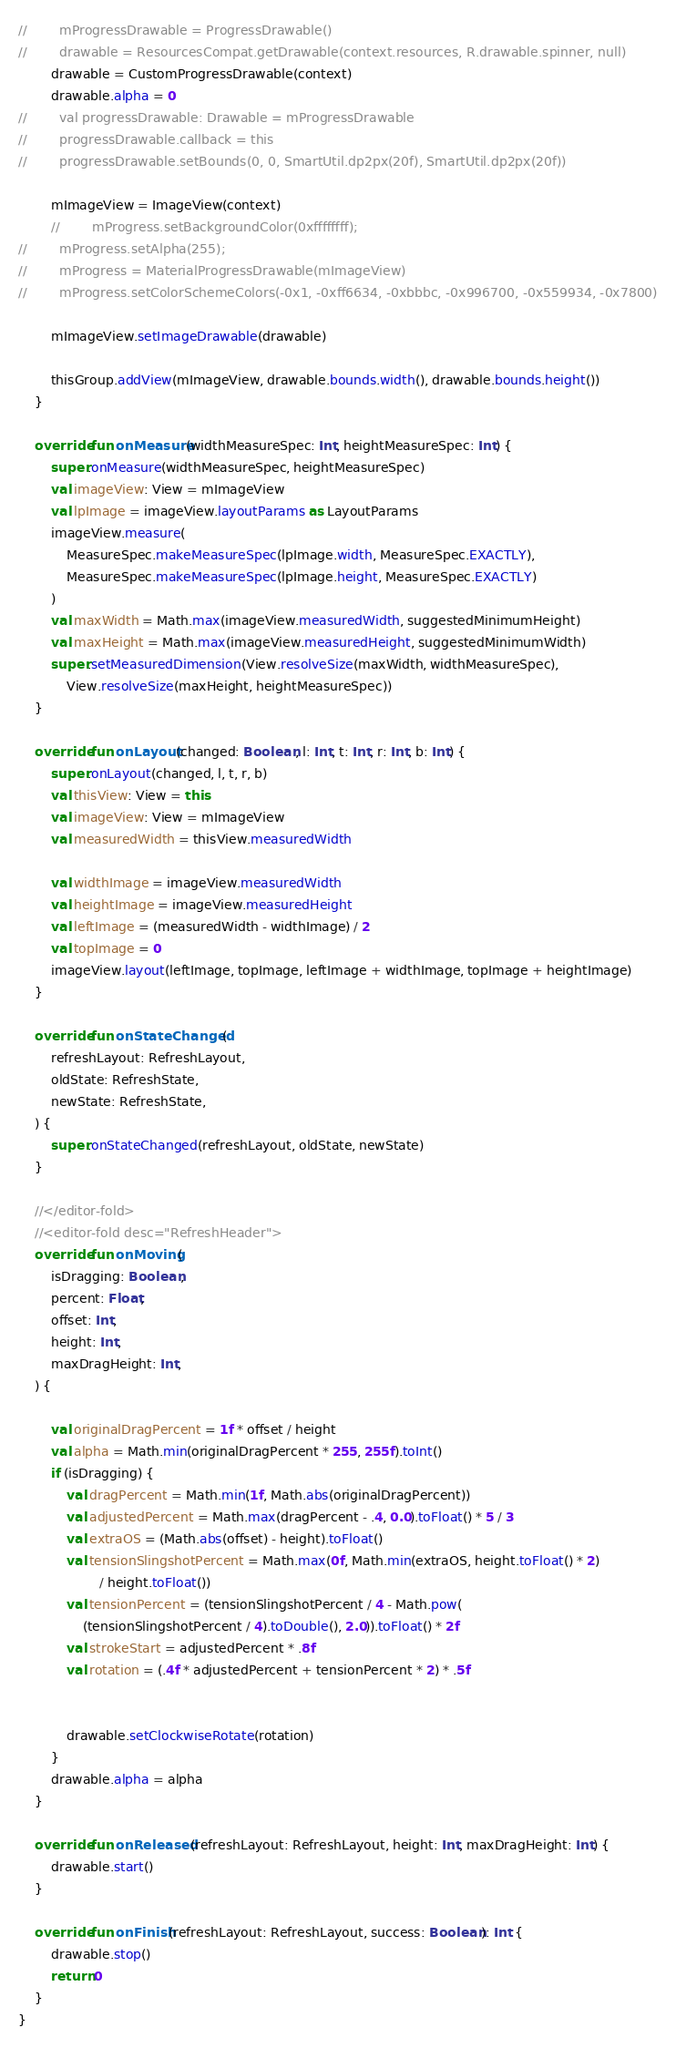Convert code to text. <code><loc_0><loc_0><loc_500><loc_500><_Kotlin_>
//        mProgressDrawable = ProgressDrawable()
//        drawable = ResourcesCompat.getDrawable(context.resources, R.drawable.spinner, null)
        drawable = CustomProgressDrawable(context)
        drawable.alpha = 0
//        val progressDrawable: Drawable = mProgressDrawable
//        progressDrawable.callback = this
//        progressDrawable.setBounds(0, 0, SmartUtil.dp2px(20f), SmartUtil.dp2px(20f))

        mImageView = ImageView(context)
        //        mProgress.setBackgroundColor(0xffffffff);
//        mProgress.setAlpha(255);
//        mProgress = MaterialProgressDrawable(mImageView)
//        mProgress.setColorSchemeColors(-0x1, -0xff6634, -0xbbbc, -0x996700, -0x559934, -0x7800)

        mImageView.setImageDrawable(drawable)

        thisGroup.addView(mImageView, drawable.bounds.width(), drawable.bounds.height())
    }

    override fun onMeasure(widthMeasureSpec: Int, heightMeasureSpec: Int) {
        super.onMeasure(widthMeasureSpec, heightMeasureSpec)
        val imageView: View = mImageView
        val lpImage = imageView.layoutParams as LayoutParams
        imageView.measure(
            MeasureSpec.makeMeasureSpec(lpImage.width, MeasureSpec.EXACTLY),
            MeasureSpec.makeMeasureSpec(lpImage.height, MeasureSpec.EXACTLY)
        )
        val maxWidth = Math.max(imageView.measuredWidth, suggestedMinimumHeight)
        val maxHeight = Math.max(imageView.measuredHeight, suggestedMinimumWidth)
        super.setMeasuredDimension(View.resolveSize(maxWidth, widthMeasureSpec),
            View.resolveSize(maxHeight, heightMeasureSpec))
    }

    override fun onLayout(changed: Boolean, l: Int, t: Int, r: Int, b: Int) {
        super.onLayout(changed, l, t, r, b)
        val thisView: View = this
        val imageView: View = mImageView
        val measuredWidth = thisView.measuredWidth

        val widthImage = imageView.measuredWidth
        val heightImage = imageView.measuredHeight
        val leftImage = (measuredWidth - widthImage) / 2
        val topImage = 0
        imageView.layout(leftImage, topImage, leftImage + widthImage, topImage + heightImage)
    }

    override fun onStateChanged(
        refreshLayout: RefreshLayout,
        oldState: RefreshState,
        newState: RefreshState,
    ) {
        super.onStateChanged(refreshLayout, oldState, newState)
    }

    //</editor-fold>
    //<editor-fold desc="RefreshHeader">
    override fun onMoving(
        isDragging: Boolean,
        percent: Float,
        offset: Int,
        height: Int,
        maxDragHeight: Int,
    ) {

        val originalDragPercent = 1f * offset / height
        val alpha = Math.min(originalDragPercent * 255, 255f).toInt()
        if (isDragging) {
            val dragPercent = Math.min(1f, Math.abs(originalDragPercent))
            val adjustedPercent = Math.max(dragPercent - .4, 0.0).toFloat() * 5 / 3
            val extraOS = (Math.abs(offset) - height).toFloat()
            val tensionSlingshotPercent = Math.max(0f, Math.min(extraOS, height.toFloat() * 2)
                    / height.toFloat())
            val tensionPercent = (tensionSlingshotPercent / 4 - Math.pow(
                (tensionSlingshotPercent / 4).toDouble(), 2.0)).toFloat() * 2f
            val strokeStart = adjustedPercent * .8f
            val rotation = (.4f * adjustedPercent + tensionPercent * 2) * .5f


            drawable.setClockwiseRotate(rotation)
        }
        drawable.alpha = alpha
    }

    override fun onReleased(refreshLayout: RefreshLayout, height: Int, maxDragHeight: Int) {
        drawable.start()
    }

    override fun onFinish(refreshLayout: RefreshLayout, success: Boolean): Int {
        drawable.stop()
        return 0
    }
}</code> 